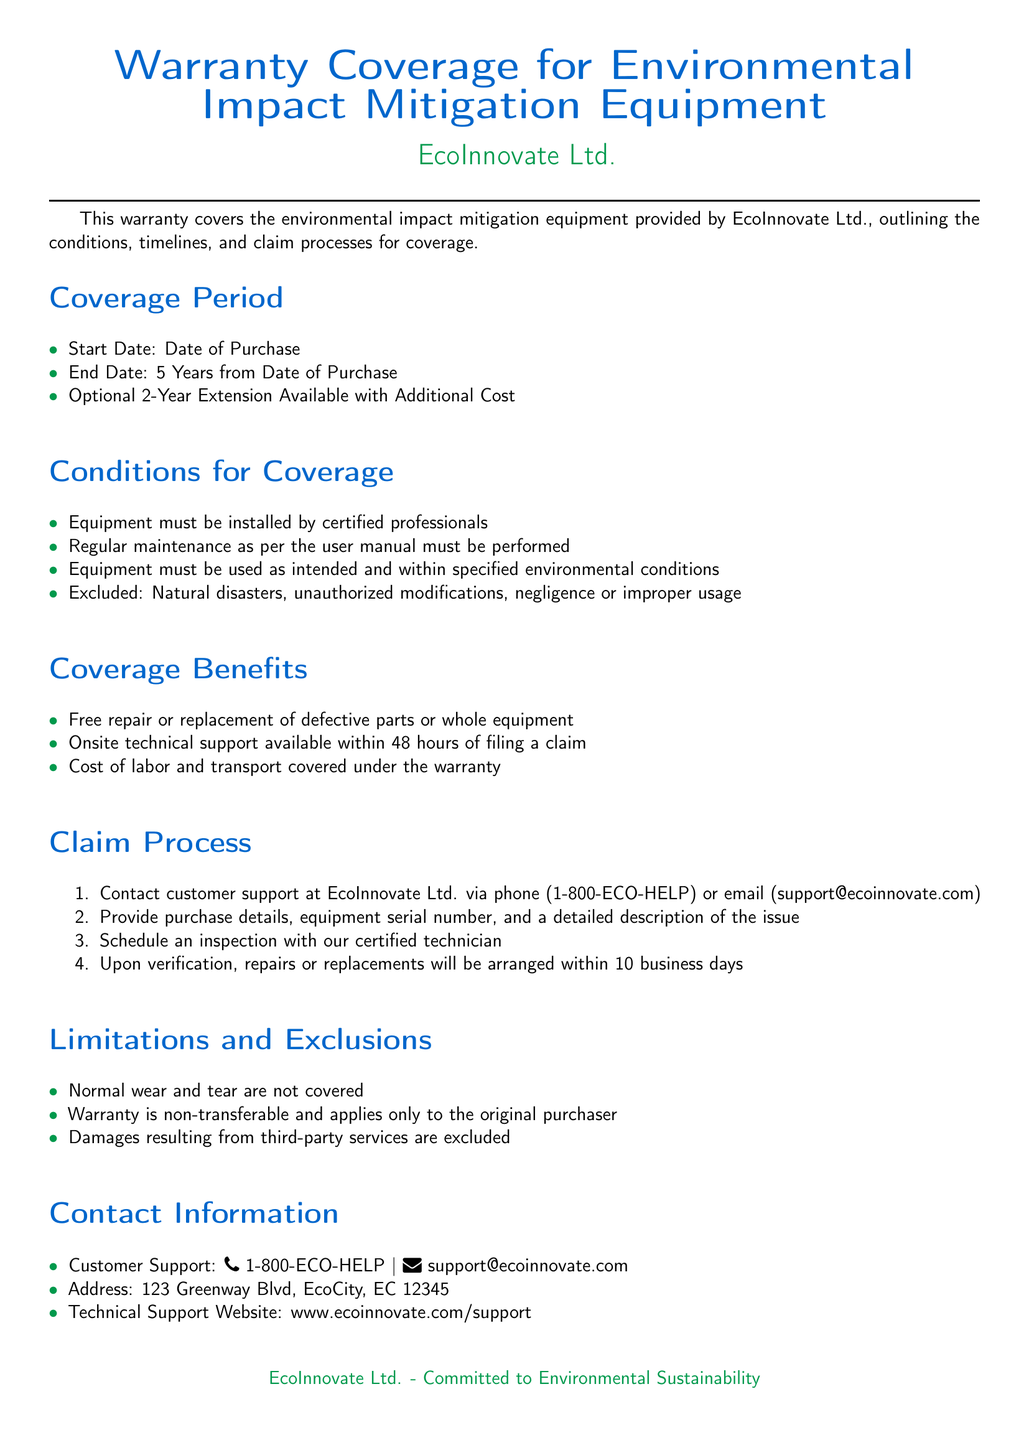What is the warranty coverage period? The warranty coverage period is from the date of purchase to five years later.
Answer: Five years What is the start date of the warranty? The start date of the warranty is the date the equipment is purchased.
Answer: Date of Purchase What is one condition for coverage under this warranty? One condition for coverage is that the equipment must be installed by certified professionals.
Answer: Installed by certified professionals What is excluded from the warranty coverage? Damages resulting from unauthorized modifications are excluded from the warranty.
Answer: Unauthorized modifications What is the timeline for repairs or replacements after verification? Repairs or replacements will be arranged within ten business days after verification.
Answer: Ten business days How long does technical support take to respond after a claim is filed? The technical support is available onsite within 48 hours of filing a claim.
Answer: 48 hours What is the optional extension available for the warranty? An optional extension of two years is available for an additional cost.
Answer: Two years What is the contact phone number for customer support? The contact phone number for customer support is displayed in the document.
Answer: 1-800-ECO-HELP 